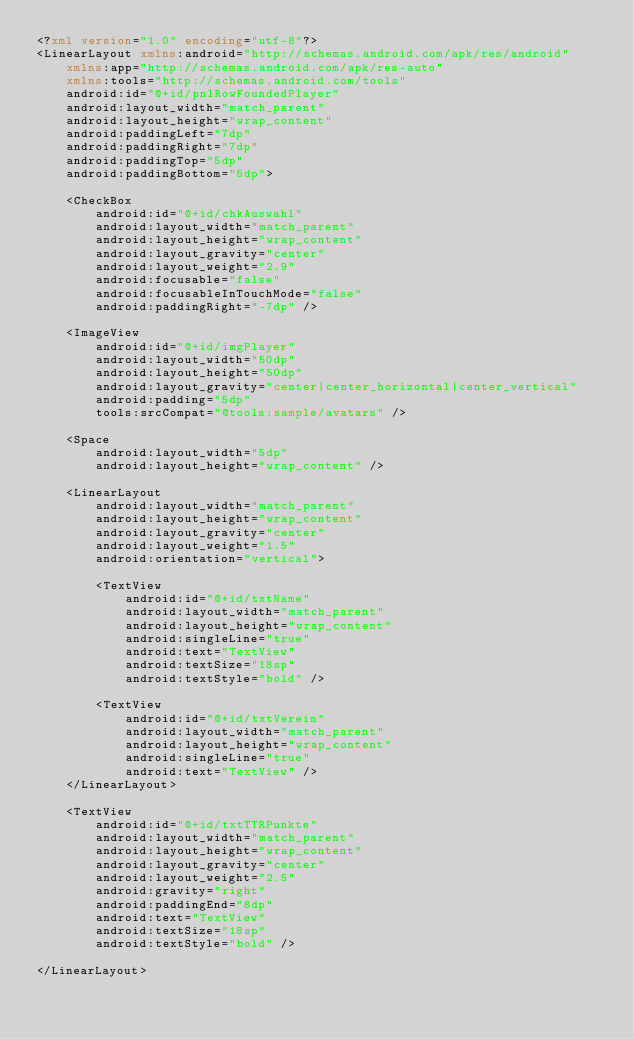<code> <loc_0><loc_0><loc_500><loc_500><_XML_><?xml version="1.0" encoding="utf-8"?>
<LinearLayout xmlns:android="http://schemas.android.com/apk/res/android"
    xmlns:app="http://schemas.android.com/apk/res-auto"
    xmlns:tools="http://schemas.android.com/tools"
    android:id="@+id/pnlRowFoundedPlayer"
    android:layout_width="match_parent"
    android:layout_height="wrap_content"
    android:paddingLeft="7dp"
    android:paddingRight="7dp"
    android:paddingTop="5dp"
    android:paddingBottom="5dp">

    <CheckBox
        android:id="@+id/chkAuswahl"
        android:layout_width="match_parent"
        android:layout_height="wrap_content"
        android:layout_gravity="center"
        android:layout_weight="2.9"
        android:focusable="false"
        android:focusableInTouchMode="false"
        android:paddingRight="-7dp" />

    <ImageView
        android:id="@+id/imgPlayer"
        android:layout_width="50dp"
        android:layout_height="50dp"
        android:layout_gravity="center|center_horizontal|center_vertical"
        android:padding="5dp"
        tools:srcCompat="@tools:sample/avatars" />

    <Space
        android:layout_width="5dp"
        android:layout_height="wrap_content" />

    <LinearLayout
        android:layout_width="match_parent"
        android:layout_height="wrap_content"
        android:layout_gravity="center"
        android:layout_weight="1.5"
        android:orientation="vertical">

        <TextView
            android:id="@+id/txtName"
            android:layout_width="match_parent"
            android:layout_height="wrap_content"
            android:singleLine="true"
            android:text="TextView"
            android:textSize="18sp"
            android:textStyle="bold" />

        <TextView
            android:id="@+id/txtVerein"
            android:layout_width="match_parent"
            android:layout_height="wrap_content"
            android:singleLine="true"
            android:text="TextView" />
    </LinearLayout>

    <TextView
        android:id="@+id/txtTTRPunkte"
        android:layout_width="match_parent"
        android:layout_height="wrap_content"
        android:layout_gravity="center"
        android:layout_weight="2.5"
        android:gravity="right"
        android:paddingEnd="8dp"
        android:text="TextView"
        android:textSize="18sp"
        android:textStyle="bold" />

</LinearLayout></code> 